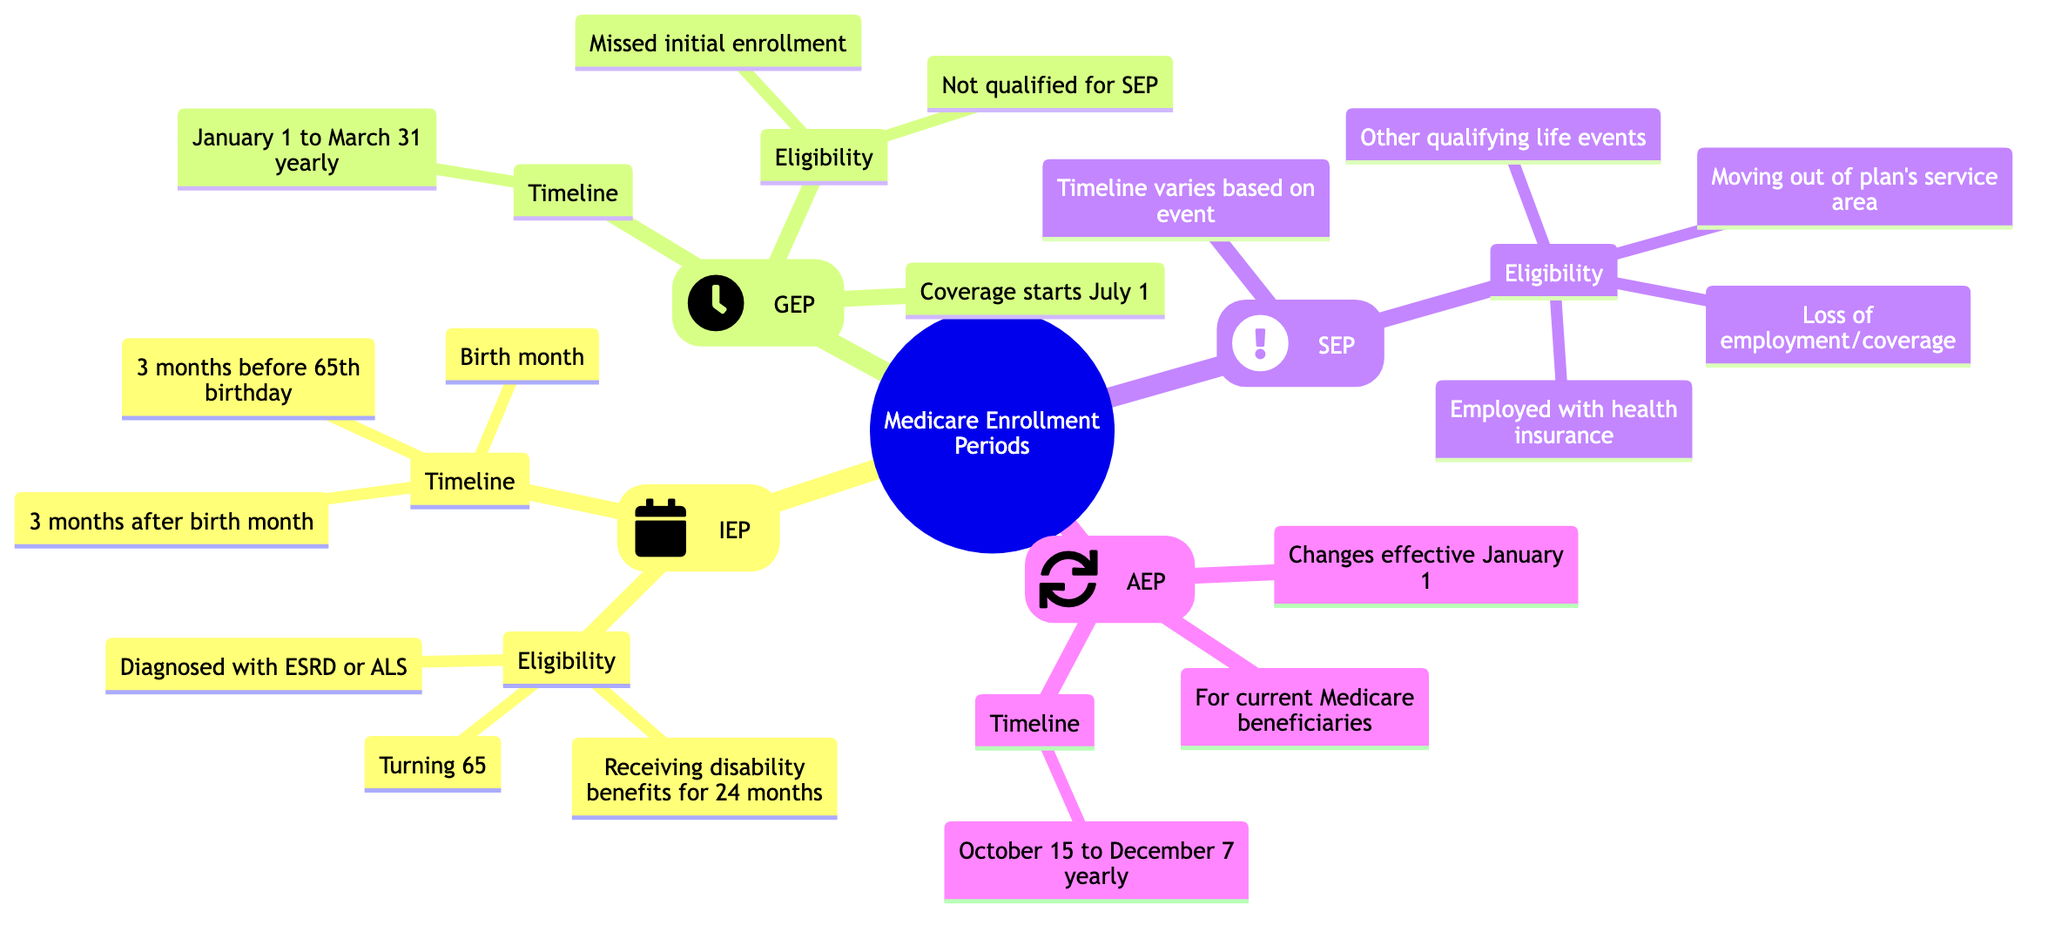What is the timeframe for the Initial Enrollment Period? The Initial Enrollment Period (IEP) begins 3 months before you turn 65, includes your birth month, and ends 3 months after your birth month. This timeline is specified in the diagram under the IEP node.
Answer: 7 months What events qualify for a Special Enrollment Period? The Special Enrollment Period (SEP) includes qualifying events such as currently being employed with health insurance, loss of employment or coverage, moving out of your plan’s service area, and experiencing other qualifying life events. These criteria are listed under the SEP node in the diagram.
Answer: 4 events What is the start date for the General Enrollment Period? According to the diagram, the General Enrollment Period (GEP) starts on January 1 of each year and continues until March 31. This is explicitly stated in the GEP node.
Answer: January 1 How long does the Annual Enrollment Period last? The Annual Enrollment Period (AEP) lasts from October 15 to December 7 each year, as indicated in the AEP portion of the diagram under the timeline description.
Answer: 54 days When does coverage begin for those enrolling during the General Enrollment Period? The diagram indicates that coverage for those who enroll during the General Enrollment Period (GEP) starts on July 1 of the same year. This specific detail is highlighted in the GEP node.
Answer: July 1 In what month does a person start their Initial Enrollment Period if they turn 65 in June? For someone who turns 65 in June, their Initial Enrollment Period (IEP) starts 3 months earlier, which is March. The IEP timeline in the diagram outlines this for any birth month.
Answer: March What are the eligibility criteria for the Annual Enrollment Period? To be eligible for the Annual Enrollment Period (AEP), a person must currently be a Medicare beneficiary with Parts A or B. This is explicitly mentioned under the AEP node in the diagram.
Answer: Current beneficiaries What is the maximum duration for a Special Enrollment Period based on a qualifying event? The Special Enrollment Period (SEP) usually lasts for 8 months after losing eligible coverage, as outlined in the SEP timeline in the diagram.
Answer: 8 months What is the Birth Month for the Initial Enrollment Period? The Birth Month is the month when the individual turns 65. This is mentioned in the timeline section of the Initial Enrollment Period (IEP) in the diagram.
Answer: Birth Month 